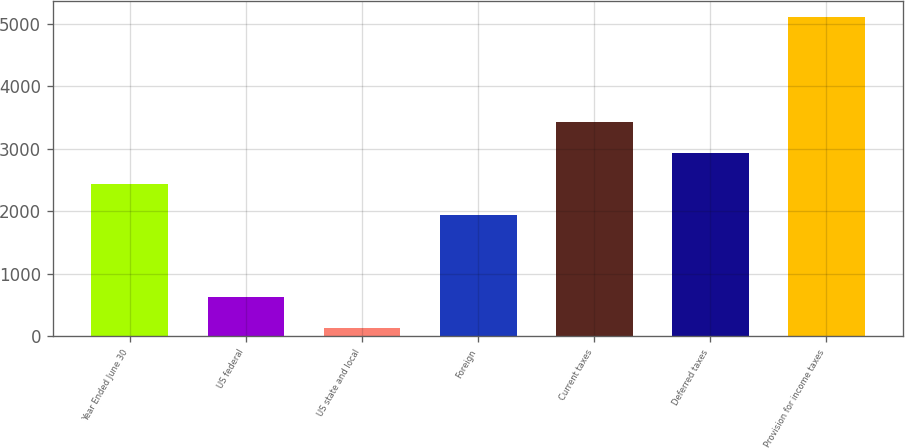Convert chart to OTSL. <chart><loc_0><loc_0><loc_500><loc_500><bar_chart><fcel>Year Ended June 30<fcel>US federal<fcel>US state and local<fcel>Foreign<fcel>Current taxes<fcel>Deferred taxes<fcel>Provision for income taxes<nl><fcel>2436.4<fcel>632.4<fcel>136<fcel>1940<fcel>3429.2<fcel>2932.8<fcel>5100<nl></chart> 